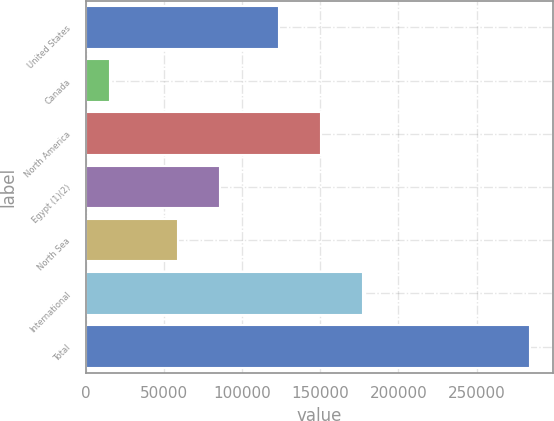Convert chart to OTSL. <chart><loc_0><loc_0><loc_500><loc_500><bar_chart><fcel>United States<fcel>Canada<fcel>North America<fcel>Egypt (1)(2)<fcel>North Sea<fcel>International<fcel>Total<nl><fcel>123666<fcel>15768<fcel>150525<fcel>86192.9<fcel>59334<fcel>177384<fcel>284357<nl></chart> 